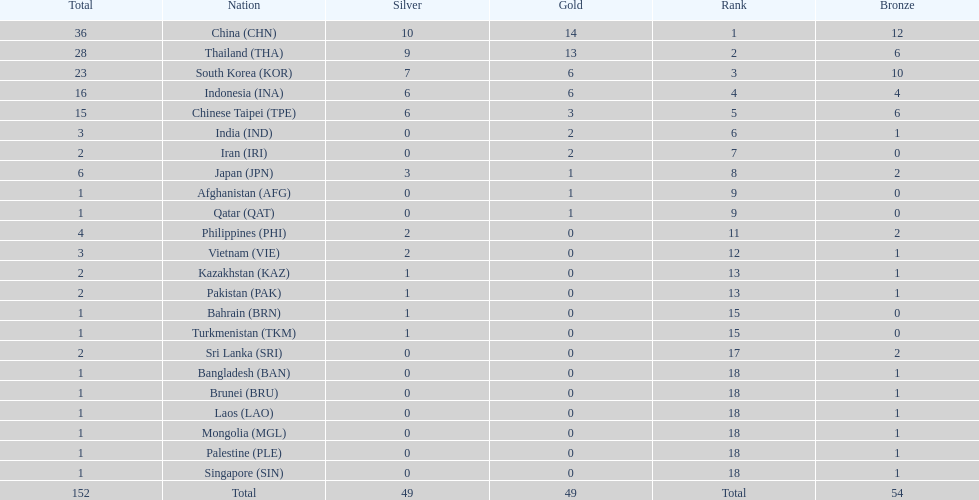How many nations received a medal in each gold, silver, and bronze? 6. 